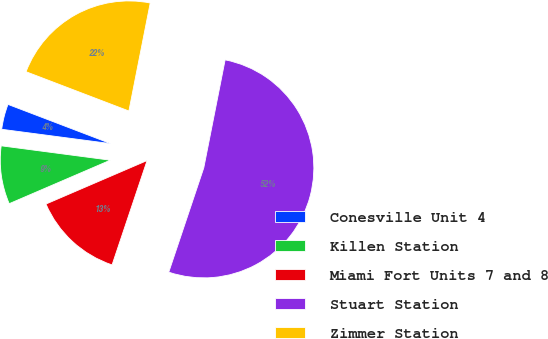Convert chart. <chart><loc_0><loc_0><loc_500><loc_500><pie_chart><fcel>Conesville Unit 4<fcel>Killen Station<fcel>Miami Fort Units 7 and 8<fcel>Stuart Station<fcel>Zimmer Station<nl><fcel>3.72%<fcel>8.55%<fcel>13.38%<fcel>52.04%<fcel>22.3%<nl></chart> 